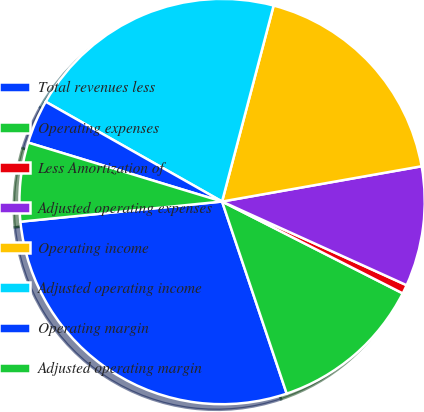<chart> <loc_0><loc_0><loc_500><loc_500><pie_chart><fcel>Total revenues less<fcel>Operating expenses<fcel>Less Amortization of<fcel>Adjusted operating expenses<fcel>Operating income<fcel>Adjusted operating income<fcel>Operating margin<fcel>Adjusted operating margin<nl><fcel>28.58%<fcel>12.35%<fcel>0.71%<fcel>9.56%<fcel>18.12%<fcel>20.9%<fcel>3.5%<fcel>6.28%<nl></chart> 